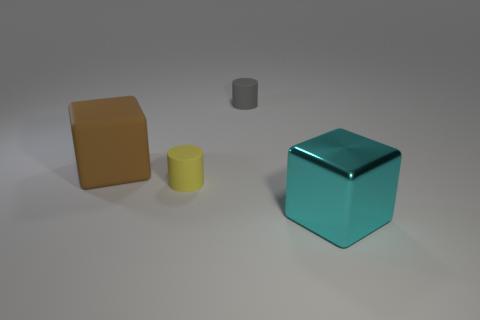How many things are either tiny things behind the large brown object or tiny metallic objects?
Offer a very short reply. 1. There is a yellow rubber cylinder; is its size the same as the cube that is to the right of the large matte cube?
Give a very brief answer. No. How many tiny things are gray shiny spheres or brown cubes?
Offer a very short reply. 0. The large brown rubber object has what shape?
Make the answer very short. Cube. Are there any other small things that have the same material as the brown object?
Offer a very short reply. Yes. Are there more small gray matte things than small rubber cylinders?
Provide a succinct answer. No. Is the material of the large cyan cube the same as the small gray object?
Ensure brevity in your answer.  No. How many metallic objects are either tiny cylinders or blue balls?
Your answer should be very brief. 0. The other block that is the same size as the brown rubber block is what color?
Your answer should be very brief. Cyan. How many small yellow things have the same shape as the gray thing?
Your response must be concise. 1. 